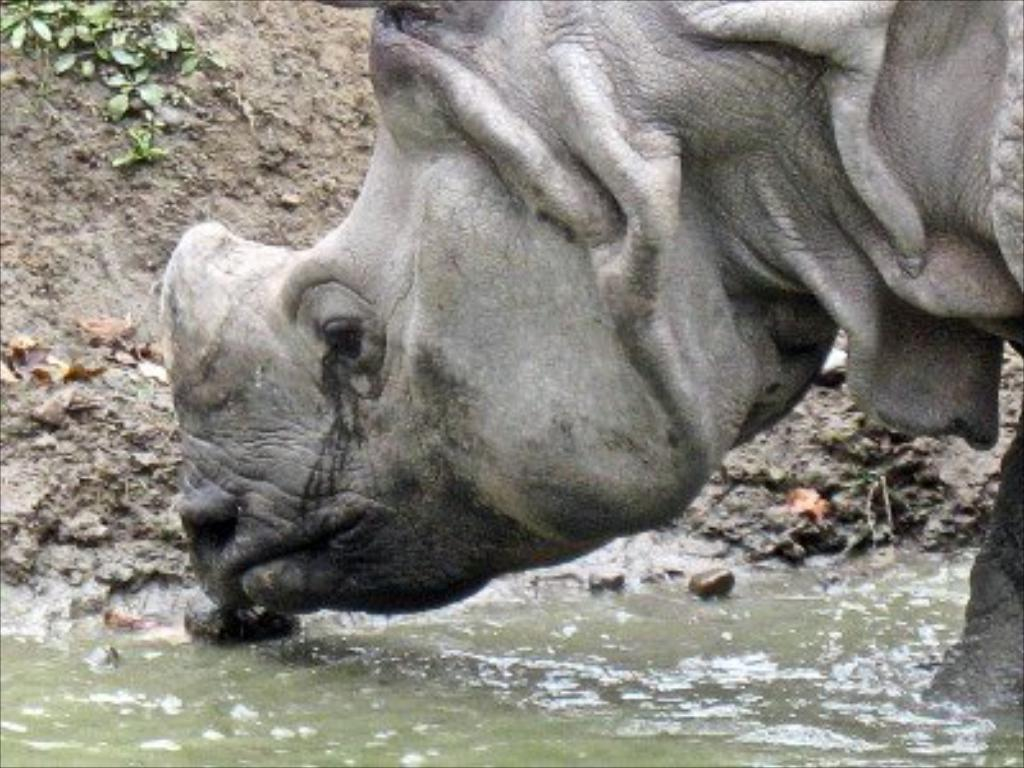What is the animal doing in the image? The animal is in the water in the image. Can you describe the animal's surroundings? The animal is in the water, which suggests that it might be swimming or submerged. What type of coat is the animal wearing in the image? There is no mention of a coat in the image, as the animal is in the water. How many feet does the animal have in the image? The number of feet the animal has cannot be determined from the image, as it is in the water and not visible. 